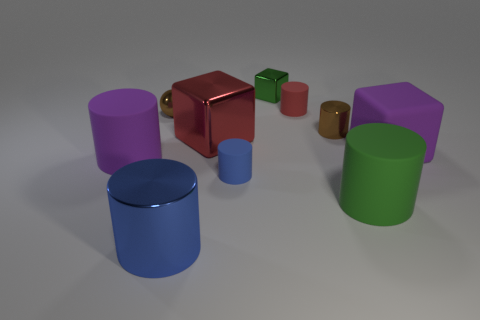Subtract all purple cylinders. How many cylinders are left? 5 Subtract all blue cylinders. How many cylinders are left? 4 Subtract all cyan cylinders. Subtract all blue balls. How many cylinders are left? 6 Subtract all balls. How many objects are left? 9 Add 2 big green rubber cylinders. How many big green rubber cylinders exist? 3 Subtract 0 gray blocks. How many objects are left? 10 Subtract all large green matte objects. Subtract all purple rubber cylinders. How many objects are left? 8 Add 1 tiny blue things. How many tiny blue things are left? 2 